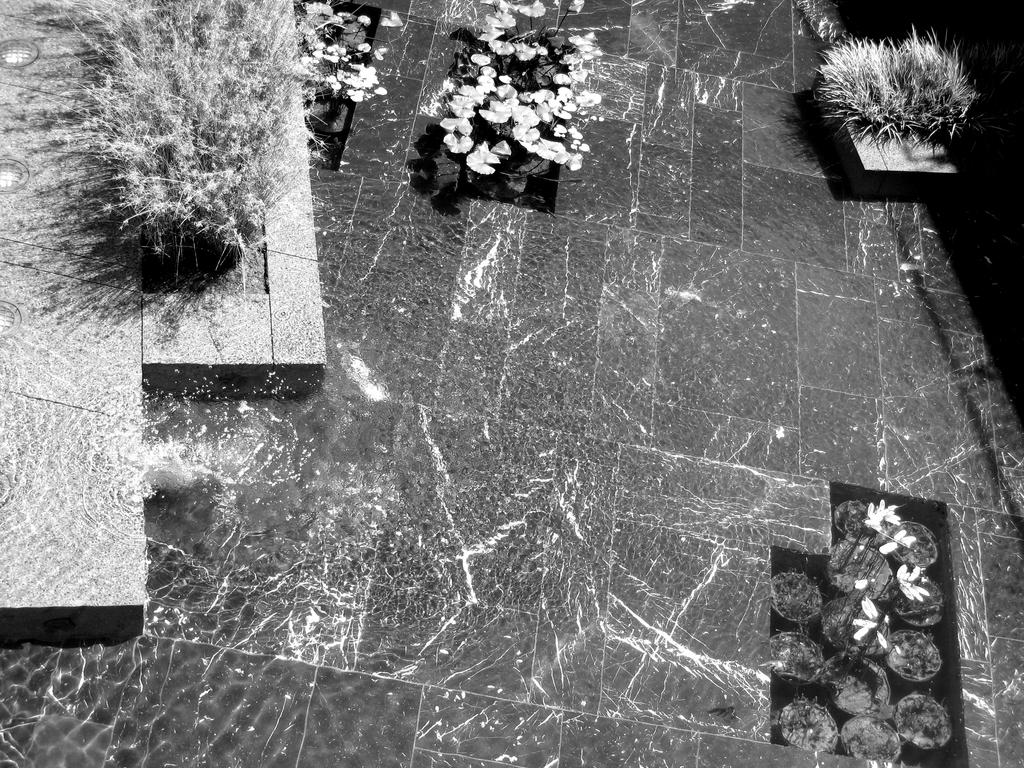What type of living organisms can be seen in the image? Plants and flowers are visible in the image. What are the plants contained in? There are pots in the image. Is there a spy hiding among the plants in the image? There is no indication of a spy or any person in the image; it only features plants and flowers. 